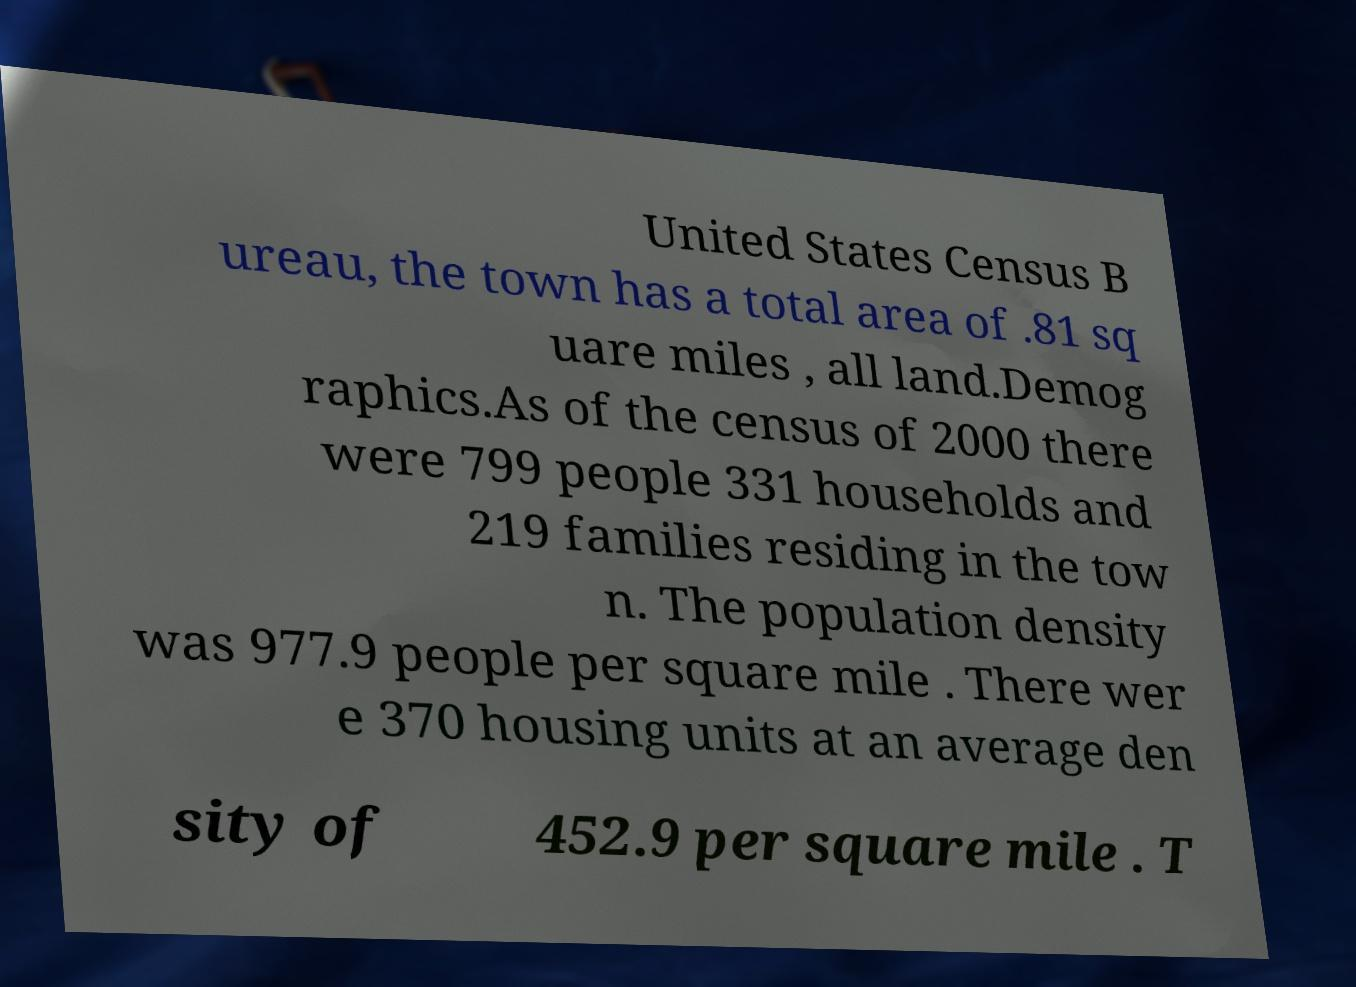Could you assist in decoding the text presented in this image and type it out clearly? United States Census B ureau, the town has a total area of .81 sq uare miles , all land.Demog raphics.As of the census of 2000 there were 799 people 331 households and 219 families residing in the tow n. The population density was 977.9 people per square mile . There wer e 370 housing units at an average den sity of 452.9 per square mile . T 